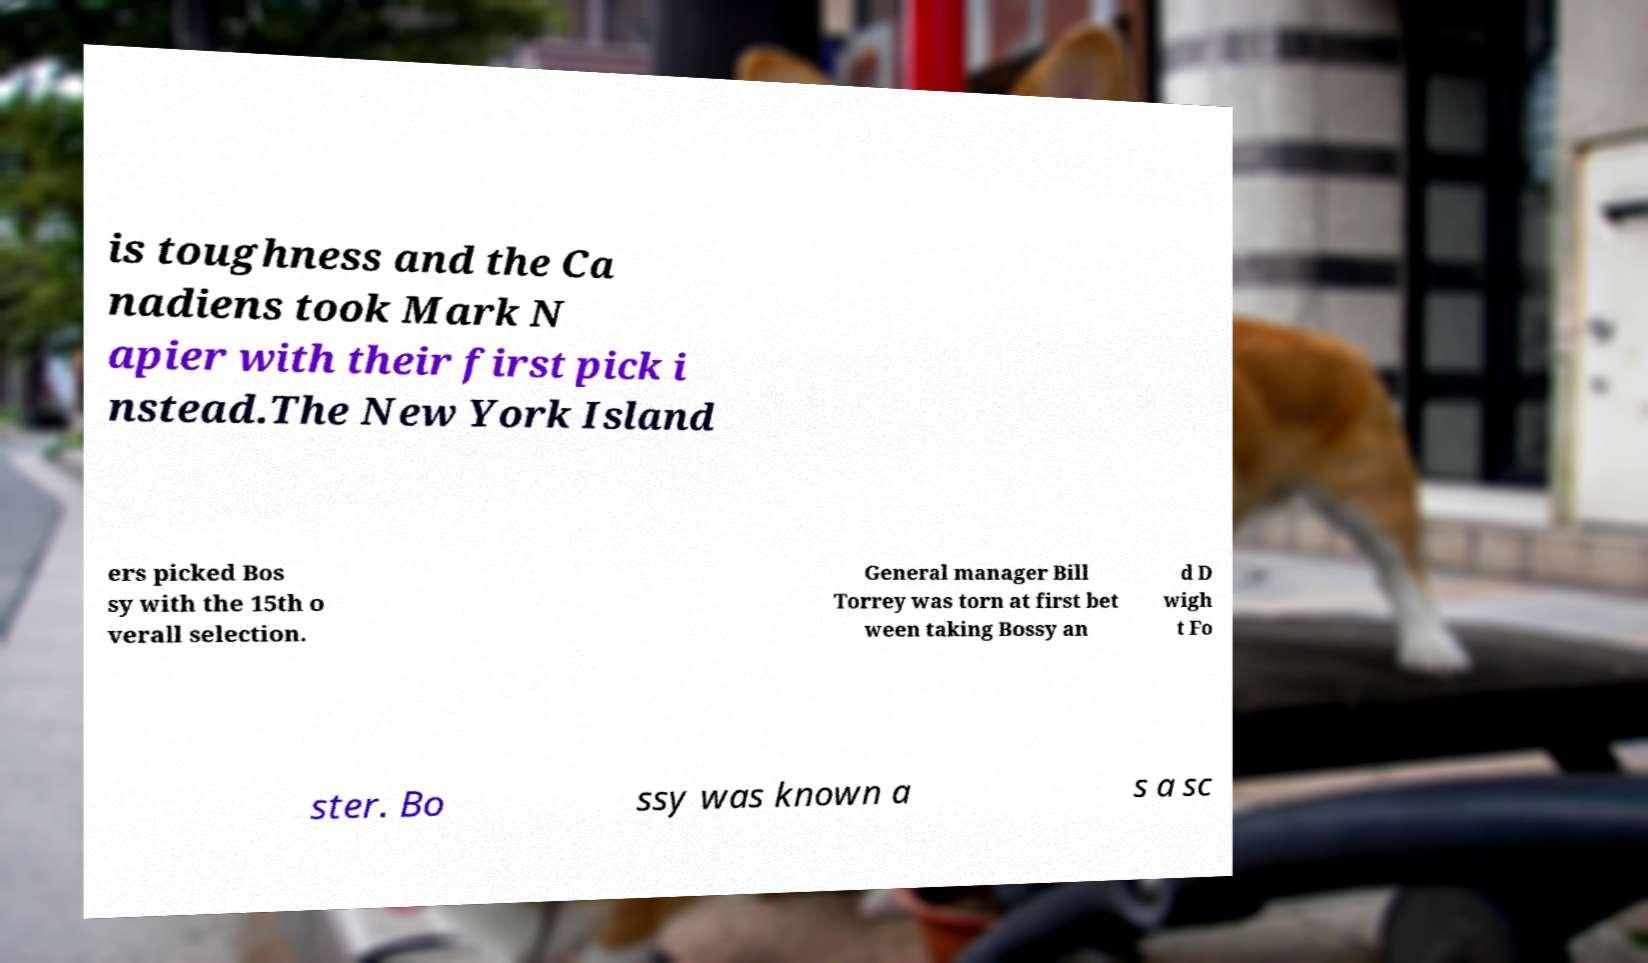Can you accurately transcribe the text from the provided image for me? is toughness and the Ca nadiens took Mark N apier with their first pick i nstead.The New York Island ers picked Bos sy with the 15th o verall selection. General manager Bill Torrey was torn at first bet ween taking Bossy an d D wigh t Fo ster. Bo ssy was known a s a sc 